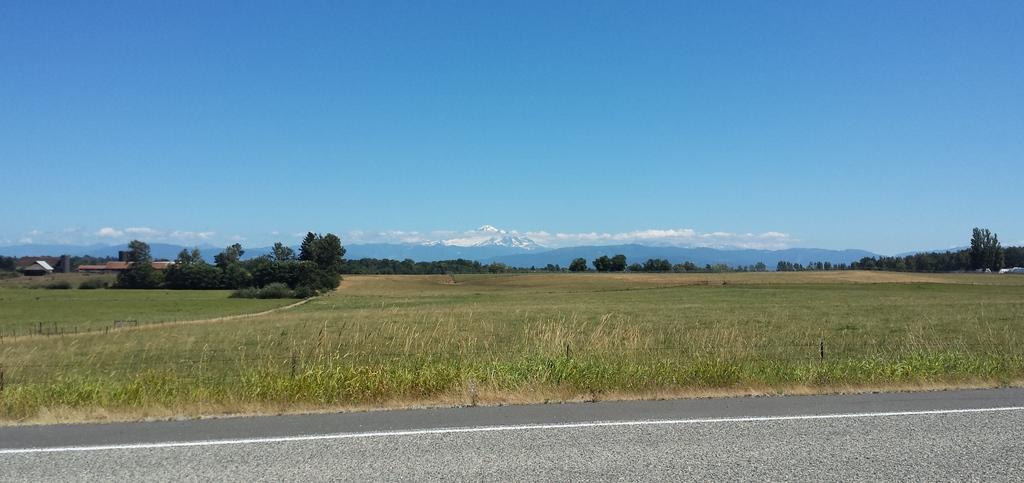Can you describe this image briefly? In this image we can see trees and grass. On the left side of the image we can see buildings and trees. At the bottom there is a road. In the background we can see hills, clouds, sky. 